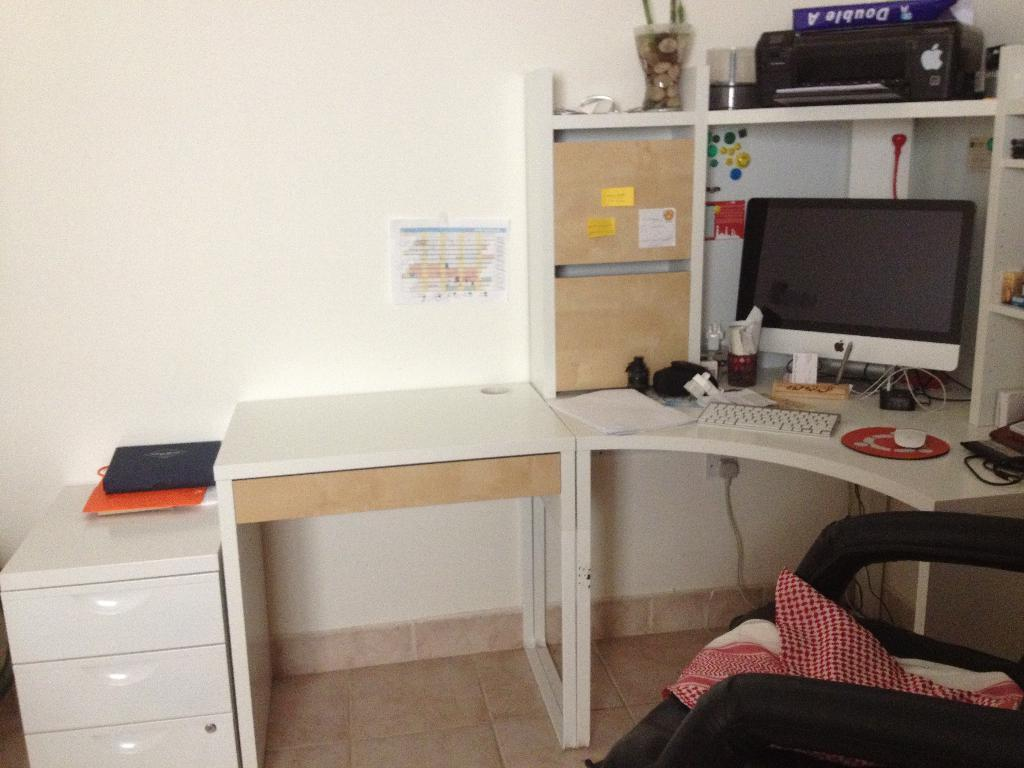What type of electronic device is visible in the image? There is a monitor in the image. What is used for input with the monitor? There is a keyboard and a mouse in the image. What else can be seen on the table besides the monitor and input devices? There are papers on the table. Where are the objects placed in the image? The objects are placed on a table. What might someone use to sit while working at the table? There is a chair in front of the table. What type of spring is visible in the image? There is no spring present in the image. What boundary is depicted in the image? The image does not show any boundaries; it is a close-up view of a workstation. 